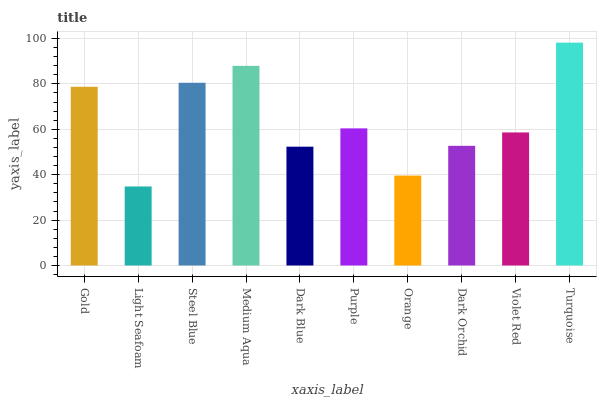Is Light Seafoam the minimum?
Answer yes or no. Yes. Is Turquoise the maximum?
Answer yes or no. Yes. Is Steel Blue the minimum?
Answer yes or no. No. Is Steel Blue the maximum?
Answer yes or no. No. Is Steel Blue greater than Light Seafoam?
Answer yes or no. Yes. Is Light Seafoam less than Steel Blue?
Answer yes or no. Yes. Is Light Seafoam greater than Steel Blue?
Answer yes or no. No. Is Steel Blue less than Light Seafoam?
Answer yes or no. No. Is Purple the high median?
Answer yes or no. Yes. Is Violet Red the low median?
Answer yes or no. Yes. Is Medium Aqua the high median?
Answer yes or no. No. Is Turquoise the low median?
Answer yes or no. No. 